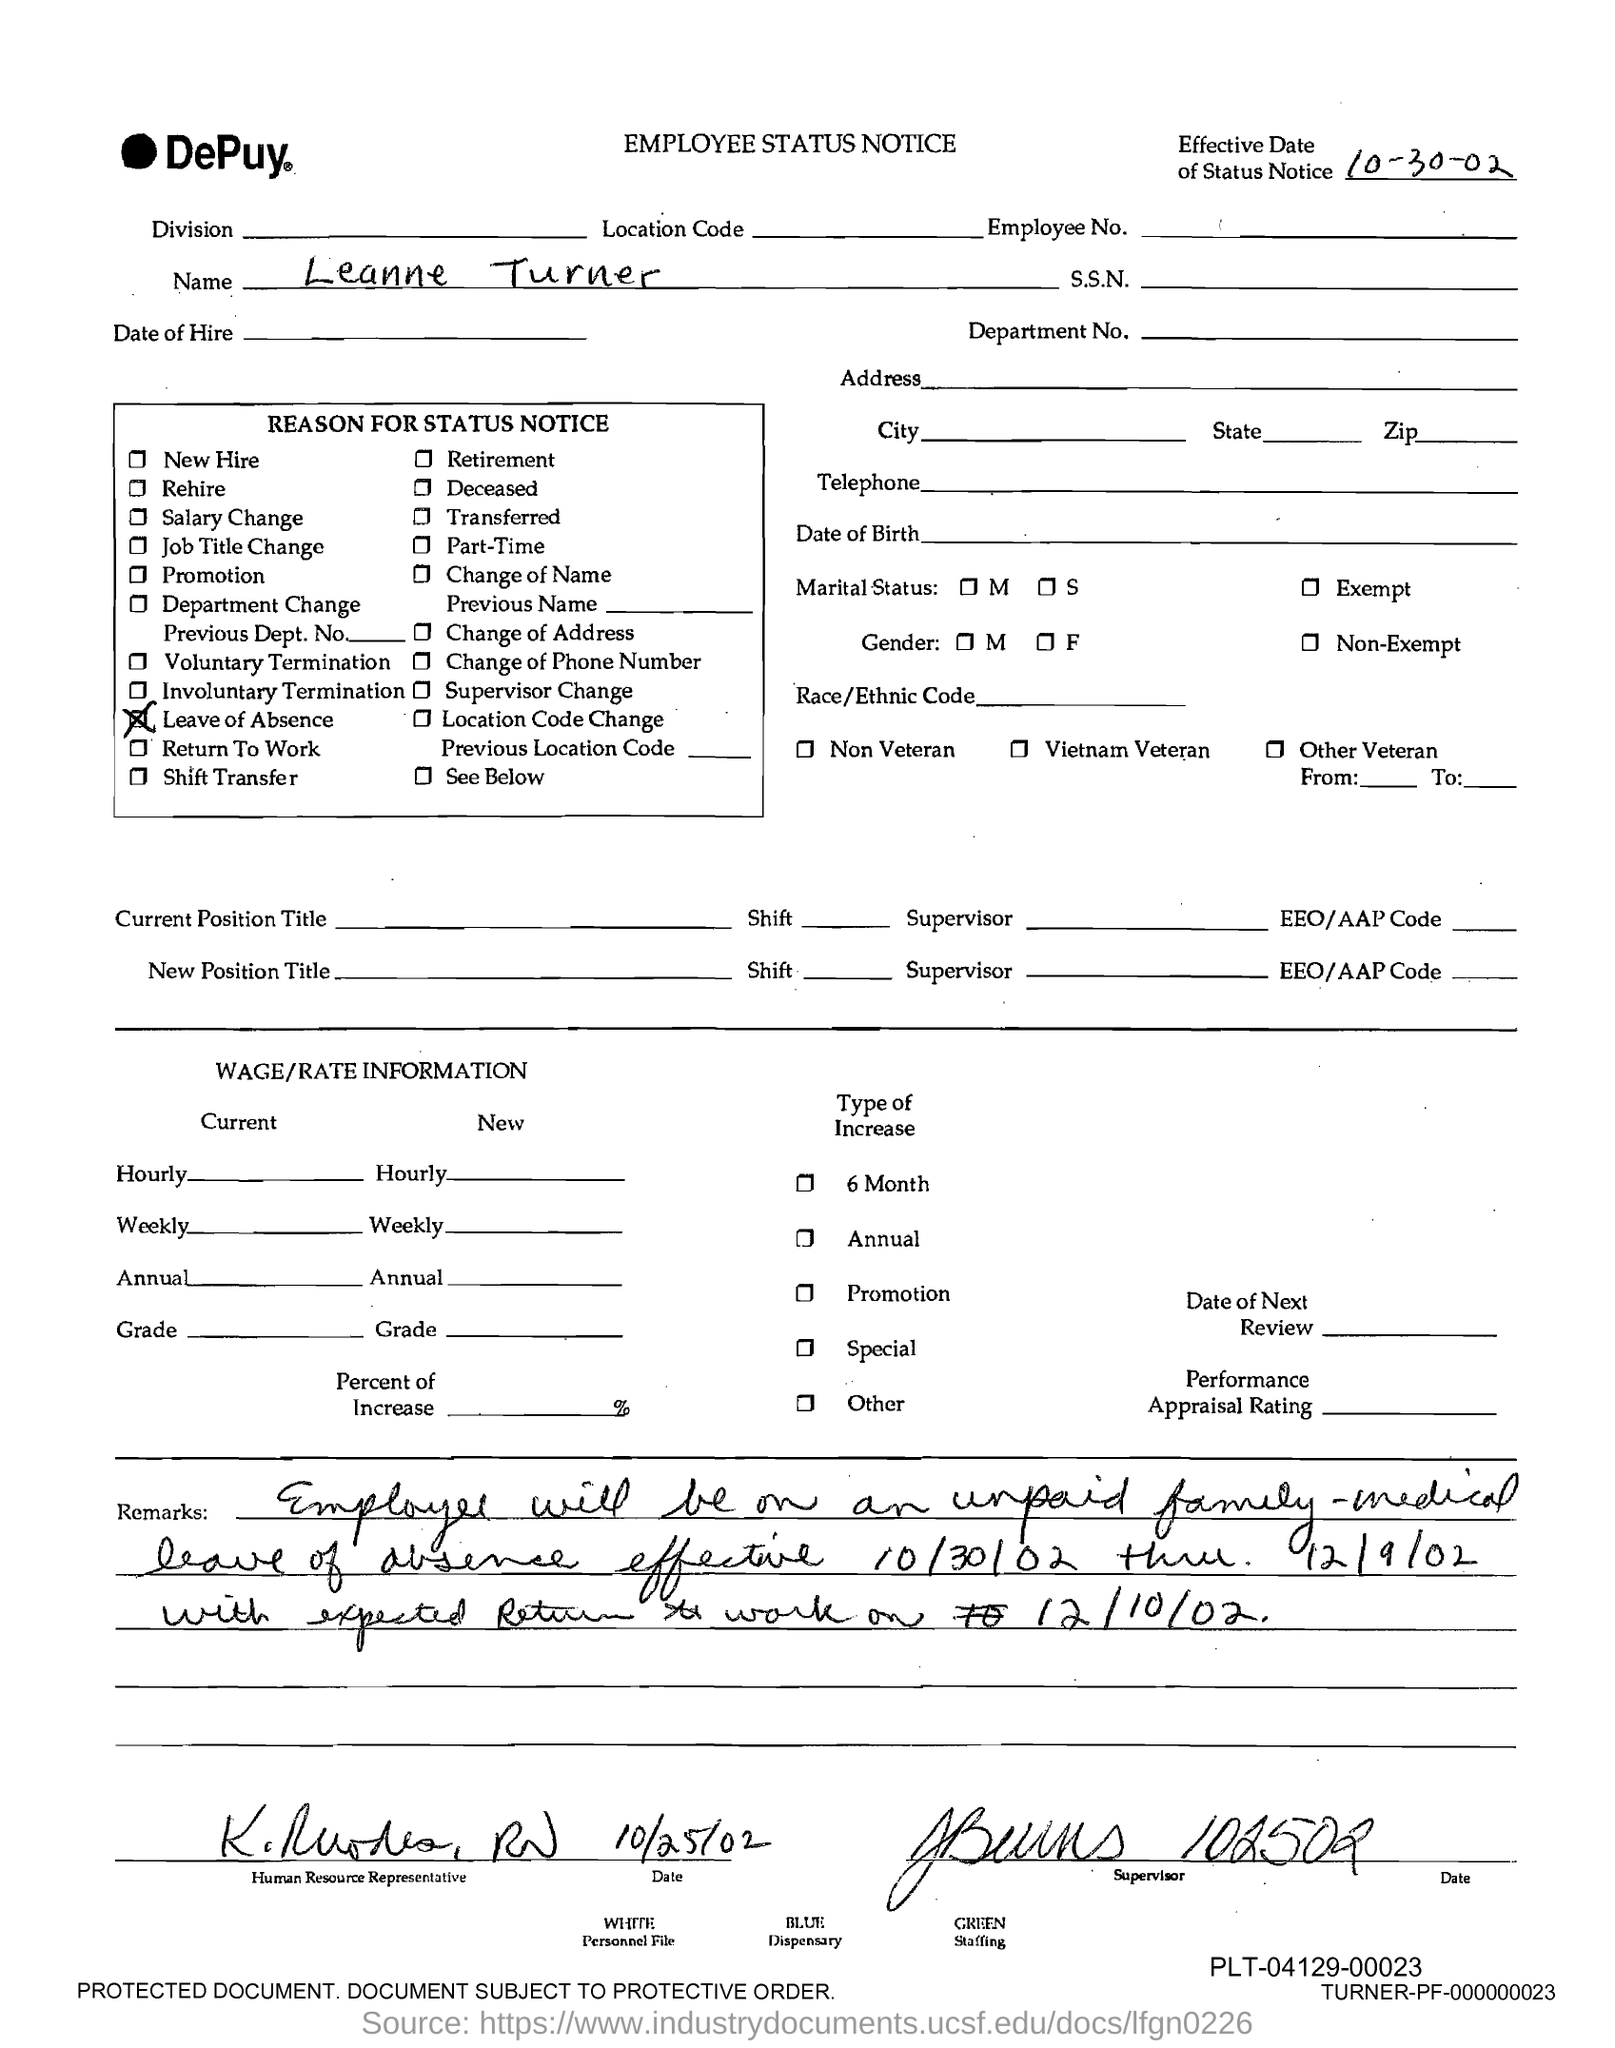Mention a couple of crucial points in this snapshot. The name provided in the employee status notice is Leanne Turner. The effective date of the status notice is October 30, 2002. This is the status notice for an employee of DePuy. I, [Your Name], am currently on a leave of absence due to [reason for leave of absence]. 